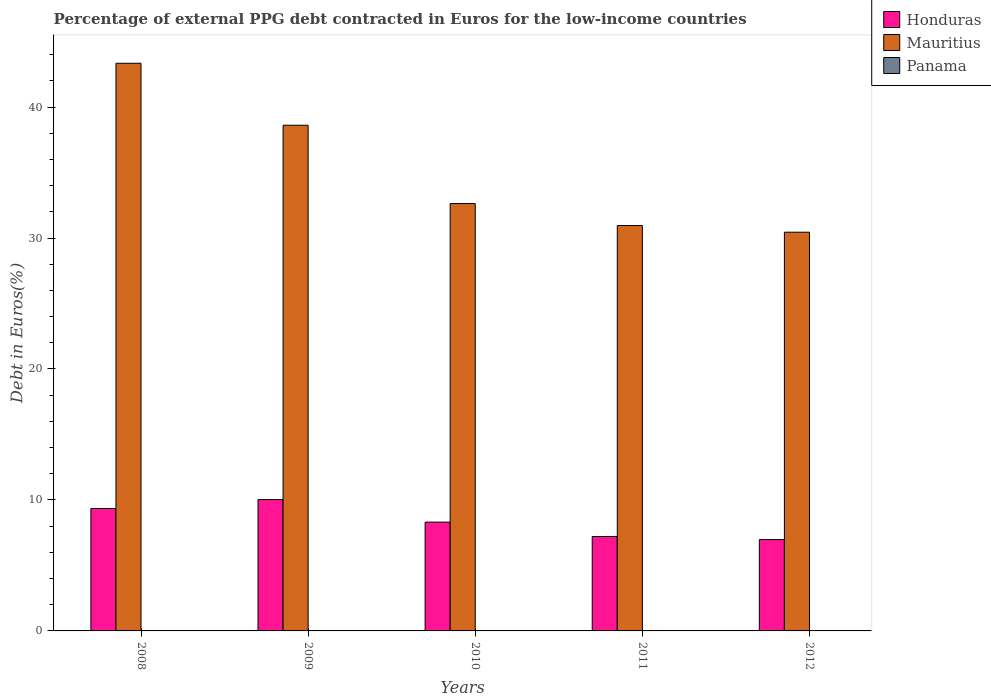How many different coloured bars are there?
Make the answer very short. 3. Are the number of bars on each tick of the X-axis equal?
Your answer should be compact. Yes. How many bars are there on the 4th tick from the left?
Provide a succinct answer. 3. How many bars are there on the 3rd tick from the right?
Provide a succinct answer. 3. What is the label of the 1st group of bars from the left?
Offer a terse response. 2008. In how many cases, is the number of bars for a given year not equal to the number of legend labels?
Keep it short and to the point. 0. What is the percentage of external PPG debt contracted in Euros in Mauritius in 2010?
Provide a short and direct response. 32.63. Across all years, what is the maximum percentage of external PPG debt contracted in Euros in Panama?
Make the answer very short. 0.03. Across all years, what is the minimum percentage of external PPG debt contracted in Euros in Panama?
Your answer should be compact. 0.01. In which year was the percentage of external PPG debt contracted in Euros in Mauritius minimum?
Your answer should be compact. 2012. What is the total percentage of external PPG debt contracted in Euros in Panama in the graph?
Your answer should be very brief. 0.08. What is the difference between the percentage of external PPG debt contracted in Euros in Honduras in 2008 and that in 2010?
Your answer should be very brief. 1.04. What is the difference between the percentage of external PPG debt contracted in Euros in Honduras in 2008 and the percentage of external PPG debt contracted in Euros in Panama in 2010?
Your answer should be very brief. 9.33. What is the average percentage of external PPG debt contracted in Euros in Honduras per year?
Offer a terse response. 8.37. In the year 2012, what is the difference between the percentage of external PPG debt contracted in Euros in Panama and percentage of external PPG debt contracted in Euros in Honduras?
Provide a short and direct response. -6.96. In how many years, is the percentage of external PPG debt contracted in Euros in Honduras greater than 6 %?
Your answer should be very brief. 5. What is the ratio of the percentage of external PPG debt contracted in Euros in Honduras in 2009 to that in 2010?
Keep it short and to the point. 1.21. Is the percentage of external PPG debt contracted in Euros in Panama in 2010 less than that in 2011?
Ensure brevity in your answer.  No. Is the difference between the percentage of external PPG debt contracted in Euros in Panama in 2011 and 2012 greater than the difference between the percentage of external PPG debt contracted in Euros in Honduras in 2011 and 2012?
Offer a terse response. No. What is the difference between the highest and the second highest percentage of external PPG debt contracted in Euros in Panama?
Offer a very short reply. 0.01. What is the difference between the highest and the lowest percentage of external PPG debt contracted in Euros in Mauritius?
Provide a succinct answer. 12.9. In how many years, is the percentage of external PPG debt contracted in Euros in Honduras greater than the average percentage of external PPG debt contracted in Euros in Honduras taken over all years?
Ensure brevity in your answer.  2. What does the 1st bar from the left in 2008 represents?
Your answer should be compact. Honduras. What does the 1st bar from the right in 2011 represents?
Your answer should be compact. Panama. Is it the case that in every year, the sum of the percentage of external PPG debt contracted in Euros in Honduras and percentage of external PPG debt contracted in Euros in Mauritius is greater than the percentage of external PPG debt contracted in Euros in Panama?
Your answer should be very brief. Yes. How many bars are there?
Keep it short and to the point. 15. Are all the bars in the graph horizontal?
Ensure brevity in your answer.  No. Are the values on the major ticks of Y-axis written in scientific E-notation?
Your response must be concise. No. Where does the legend appear in the graph?
Your response must be concise. Top right. How are the legend labels stacked?
Offer a terse response. Vertical. What is the title of the graph?
Give a very brief answer. Percentage of external PPG debt contracted in Euros for the low-income countries. Does "Italy" appear as one of the legend labels in the graph?
Your answer should be compact. No. What is the label or title of the X-axis?
Offer a very short reply. Years. What is the label or title of the Y-axis?
Your answer should be compact. Debt in Euros(%). What is the Debt in Euros(%) in Honduras in 2008?
Offer a very short reply. 9.35. What is the Debt in Euros(%) of Mauritius in 2008?
Make the answer very short. 43.35. What is the Debt in Euros(%) of Panama in 2008?
Your answer should be very brief. 0.03. What is the Debt in Euros(%) of Honduras in 2009?
Your answer should be compact. 10.03. What is the Debt in Euros(%) of Mauritius in 2009?
Provide a short and direct response. 38.61. What is the Debt in Euros(%) in Panama in 2009?
Make the answer very short. 0.02. What is the Debt in Euros(%) of Honduras in 2010?
Provide a short and direct response. 8.31. What is the Debt in Euros(%) in Mauritius in 2010?
Your answer should be very brief. 32.63. What is the Debt in Euros(%) of Panama in 2010?
Your answer should be very brief. 0.01. What is the Debt in Euros(%) of Honduras in 2011?
Give a very brief answer. 7.21. What is the Debt in Euros(%) of Mauritius in 2011?
Ensure brevity in your answer.  30.96. What is the Debt in Euros(%) in Panama in 2011?
Your response must be concise. 0.01. What is the Debt in Euros(%) in Honduras in 2012?
Keep it short and to the point. 6.97. What is the Debt in Euros(%) of Mauritius in 2012?
Your answer should be very brief. 30.45. What is the Debt in Euros(%) of Panama in 2012?
Offer a very short reply. 0.01. Across all years, what is the maximum Debt in Euros(%) in Honduras?
Your response must be concise. 10.03. Across all years, what is the maximum Debt in Euros(%) in Mauritius?
Your response must be concise. 43.35. Across all years, what is the maximum Debt in Euros(%) in Panama?
Offer a terse response. 0.03. Across all years, what is the minimum Debt in Euros(%) in Honduras?
Provide a succinct answer. 6.97. Across all years, what is the minimum Debt in Euros(%) in Mauritius?
Ensure brevity in your answer.  30.45. Across all years, what is the minimum Debt in Euros(%) of Panama?
Provide a succinct answer. 0.01. What is the total Debt in Euros(%) of Honduras in the graph?
Your response must be concise. 41.87. What is the total Debt in Euros(%) of Mauritius in the graph?
Provide a short and direct response. 175.99. What is the total Debt in Euros(%) of Panama in the graph?
Keep it short and to the point. 0.08. What is the difference between the Debt in Euros(%) of Honduras in 2008 and that in 2009?
Provide a short and direct response. -0.68. What is the difference between the Debt in Euros(%) of Mauritius in 2008 and that in 2009?
Your answer should be compact. 4.73. What is the difference between the Debt in Euros(%) in Panama in 2008 and that in 2009?
Provide a short and direct response. 0.01. What is the difference between the Debt in Euros(%) of Honduras in 2008 and that in 2010?
Provide a succinct answer. 1.04. What is the difference between the Debt in Euros(%) in Mauritius in 2008 and that in 2010?
Give a very brief answer. 10.71. What is the difference between the Debt in Euros(%) of Panama in 2008 and that in 2010?
Your response must be concise. 0.02. What is the difference between the Debt in Euros(%) of Honduras in 2008 and that in 2011?
Ensure brevity in your answer.  2.14. What is the difference between the Debt in Euros(%) of Mauritius in 2008 and that in 2011?
Make the answer very short. 12.39. What is the difference between the Debt in Euros(%) in Panama in 2008 and that in 2011?
Provide a short and direct response. 0.02. What is the difference between the Debt in Euros(%) in Honduras in 2008 and that in 2012?
Offer a very short reply. 2.38. What is the difference between the Debt in Euros(%) in Mauritius in 2008 and that in 2012?
Your answer should be compact. 12.9. What is the difference between the Debt in Euros(%) in Panama in 2008 and that in 2012?
Your answer should be compact. 0.02. What is the difference between the Debt in Euros(%) in Honduras in 2009 and that in 2010?
Your response must be concise. 1.72. What is the difference between the Debt in Euros(%) of Mauritius in 2009 and that in 2010?
Keep it short and to the point. 5.98. What is the difference between the Debt in Euros(%) in Panama in 2009 and that in 2010?
Offer a very short reply. 0. What is the difference between the Debt in Euros(%) in Honduras in 2009 and that in 2011?
Provide a succinct answer. 2.82. What is the difference between the Debt in Euros(%) of Mauritius in 2009 and that in 2011?
Offer a terse response. 7.66. What is the difference between the Debt in Euros(%) of Panama in 2009 and that in 2011?
Give a very brief answer. 0.01. What is the difference between the Debt in Euros(%) of Honduras in 2009 and that in 2012?
Provide a succinct answer. 3.06. What is the difference between the Debt in Euros(%) in Mauritius in 2009 and that in 2012?
Provide a short and direct response. 8.17. What is the difference between the Debt in Euros(%) in Panama in 2009 and that in 2012?
Provide a short and direct response. 0.01. What is the difference between the Debt in Euros(%) of Honduras in 2010 and that in 2011?
Give a very brief answer. 1.1. What is the difference between the Debt in Euros(%) in Mauritius in 2010 and that in 2011?
Provide a short and direct response. 1.68. What is the difference between the Debt in Euros(%) in Panama in 2010 and that in 2011?
Provide a short and direct response. 0. What is the difference between the Debt in Euros(%) of Honduras in 2010 and that in 2012?
Ensure brevity in your answer.  1.34. What is the difference between the Debt in Euros(%) of Mauritius in 2010 and that in 2012?
Ensure brevity in your answer.  2.19. What is the difference between the Debt in Euros(%) of Panama in 2010 and that in 2012?
Provide a succinct answer. 0. What is the difference between the Debt in Euros(%) in Honduras in 2011 and that in 2012?
Your answer should be compact. 0.24. What is the difference between the Debt in Euros(%) of Mauritius in 2011 and that in 2012?
Your answer should be compact. 0.51. What is the difference between the Debt in Euros(%) of Panama in 2011 and that in 2012?
Your answer should be compact. 0. What is the difference between the Debt in Euros(%) in Honduras in 2008 and the Debt in Euros(%) in Mauritius in 2009?
Ensure brevity in your answer.  -29.27. What is the difference between the Debt in Euros(%) of Honduras in 2008 and the Debt in Euros(%) of Panama in 2009?
Your response must be concise. 9.33. What is the difference between the Debt in Euros(%) in Mauritius in 2008 and the Debt in Euros(%) in Panama in 2009?
Your answer should be very brief. 43.33. What is the difference between the Debt in Euros(%) in Honduras in 2008 and the Debt in Euros(%) in Mauritius in 2010?
Offer a terse response. -23.28. What is the difference between the Debt in Euros(%) in Honduras in 2008 and the Debt in Euros(%) in Panama in 2010?
Make the answer very short. 9.33. What is the difference between the Debt in Euros(%) in Mauritius in 2008 and the Debt in Euros(%) in Panama in 2010?
Your response must be concise. 43.33. What is the difference between the Debt in Euros(%) in Honduras in 2008 and the Debt in Euros(%) in Mauritius in 2011?
Offer a terse response. -21.61. What is the difference between the Debt in Euros(%) in Honduras in 2008 and the Debt in Euros(%) in Panama in 2011?
Your answer should be very brief. 9.34. What is the difference between the Debt in Euros(%) of Mauritius in 2008 and the Debt in Euros(%) of Panama in 2011?
Give a very brief answer. 43.33. What is the difference between the Debt in Euros(%) of Honduras in 2008 and the Debt in Euros(%) of Mauritius in 2012?
Your answer should be very brief. -21.1. What is the difference between the Debt in Euros(%) of Honduras in 2008 and the Debt in Euros(%) of Panama in 2012?
Offer a terse response. 9.34. What is the difference between the Debt in Euros(%) in Mauritius in 2008 and the Debt in Euros(%) in Panama in 2012?
Offer a very short reply. 43.34. What is the difference between the Debt in Euros(%) in Honduras in 2009 and the Debt in Euros(%) in Mauritius in 2010?
Offer a terse response. -22.6. What is the difference between the Debt in Euros(%) of Honduras in 2009 and the Debt in Euros(%) of Panama in 2010?
Your response must be concise. 10.01. What is the difference between the Debt in Euros(%) of Mauritius in 2009 and the Debt in Euros(%) of Panama in 2010?
Offer a very short reply. 38.6. What is the difference between the Debt in Euros(%) of Honduras in 2009 and the Debt in Euros(%) of Mauritius in 2011?
Ensure brevity in your answer.  -20.93. What is the difference between the Debt in Euros(%) of Honduras in 2009 and the Debt in Euros(%) of Panama in 2011?
Your answer should be very brief. 10.02. What is the difference between the Debt in Euros(%) in Mauritius in 2009 and the Debt in Euros(%) in Panama in 2011?
Your response must be concise. 38.6. What is the difference between the Debt in Euros(%) of Honduras in 2009 and the Debt in Euros(%) of Mauritius in 2012?
Provide a succinct answer. -20.42. What is the difference between the Debt in Euros(%) of Honduras in 2009 and the Debt in Euros(%) of Panama in 2012?
Your answer should be very brief. 10.02. What is the difference between the Debt in Euros(%) in Mauritius in 2009 and the Debt in Euros(%) in Panama in 2012?
Give a very brief answer. 38.6. What is the difference between the Debt in Euros(%) in Honduras in 2010 and the Debt in Euros(%) in Mauritius in 2011?
Provide a short and direct response. -22.65. What is the difference between the Debt in Euros(%) in Honduras in 2010 and the Debt in Euros(%) in Panama in 2011?
Your response must be concise. 8.3. What is the difference between the Debt in Euros(%) of Mauritius in 2010 and the Debt in Euros(%) of Panama in 2011?
Make the answer very short. 32.62. What is the difference between the Debt in Euros(%) of Honduras in 2010 and the Debt in Euros(%) of Mauritius in 2012?
Give a very brief answer. -22.14. What is the difference between the Debt in Euros(%) in Honduras in 2010 and the Debt in Euros(%) in Panama in 2012?
Keep it short and to the point. 8.3. What is the difference between the Debt in Euros(%) of Mauritius in 2010 and the Debt in Euros(%) of Panama in 2012?
Offer a very short reply. 32.62. What is the difference between the Debt in Euros(%) of Honduras in 2011 and the Debt in Euros(%) of Mauritius in 2012?
Your response must be concise. -23.24. What is the difference between the Debt in Euros(%) in Honduras in 2011 and the Debt in Euros(%) in Panama in 2012?
Offer a very short reply. 7.2. What is the difference between the Debt in Euros(%) of Mauritius in 2011 and the Debt in Euros(%) of Panama in 2012?
Your response must be concise. 30.95. What is the average Debt in Euros(%) of Honduras per year?
Keep it short and to the point. 8.37. What is the average Debt in Euros(%) in Mauritius per year?
Give a very brief answer. 35.2. What is the average Debt in Euros(%) of Panama per year?
Your response must be concise. 0.02. In the year 2008, what is the difference between the Debt in Euros(%) in Honduras and Debt in Euros(%) in Mauritius?
Give a very brief answer. -34. In the year 2008, what is the difference between the Debt in Euros(%) of Honduras and Debt in Euros(%) of Panama?
Offer a very short reply. 9.32. In the year 2008, what is the difference between the Debt in Euros(%) in Mauritius and Debt in Euros(%) in Panama?
Your answer should be compact. 43.31. In the year 2009, what is the difference between the Debt in Euros(%) in Honduras and Debt in Euros(%) in Mauritius?
Ensure brevity in your answer.  -28.59. In the year 2009, what is the difference between the Debt in Euros(%) in Honduras and Debt in Euros(%) in Panama?
Make the answer very short. 10.01. In the year 2009, what is the difference between the Debt in Euros(%) in Mauritius and Debt in Euros(%) in Panama?
Offer a terse response. 38.6. In the year 2010, what is the difference between the Debt in Euros(%) in Honduras and Debt in Euros(%) in Mauritius?
Provide a short and direct response. -24.32. In the year 2010, what is the difference between the Debt in Euros(%) of Honduras and Debt in Euros(%) of Panama?
Give a very brief answer. 8.29. In the year 2010, what is the difference between the Debt in Euros(%) in Mauritius and Debt in Euros(%) in Panama?
Your answer should be compact. 32.62. In the year 2011, what is the difference between the Debt in Euros(%) of Honduras and Debt in Euros(%) of Mauritius?
Your response must be concise. -23.75. In the year 2011, what is the difference between the Debt in Euros(%) in Honduras and Debt in Euros(%) in Panama?
Provide a succinct answer. 7.2. In the year 2011, what is the difference between the Debt in Euros(%) in Mauritius and Debt in Euros(%) in Panama?
Your response must be concise. 30.95. In the year 2012, what is the difference between the Debt in Euros(%) of Honduras and Debt in Euros(%) of Mauritius?
Give a very brief answer. -23.47. In the year 2012, what is the difference between the Debt in Euros(%) of Honduras and Debt in Euros(%) of Panama?
Keep it short and to the point. 6.96. In the year 2012, what is the difference between the Debt in Euros(%) of Mauritius and Debt in Euros(%) of Panama?
Provide a short and direct response. 30.44. What is the ratio of the Debt in Euros(%) of Honduras in 2008 to that in 2009?
Your answer should be very brief. 0.93. What is the ratio of the Debt in Euros(%) in Mauritius in 2008 to that in 2009?
Ensure brevity in your answer.  1.12. What is the ratio of the Debt in Euros(%) of Panama in 2008 to that in 2009?
Offer a terse response. 1.89. What is the ratio of the Debt in Euros(%) in Honduras in 2008 to that in 2010?
Your response must be concise. 1.13. What is the ratio of the Debt in Euros(%) in Mauritius in 2008 to that in 2010?
Your response must be concise. 1.33. What is the ratio of the Debt in Euros(%) in Panama in 2008 to that in 2010?
Keep it short and to the point. 2.23. What is the ratio of the Debt in Euros(%) in Honduras in 2008 to that in 2011?
Provide a short and direct response. 1.3. What is the ratio of the Debt in Euros(%) in Mauritius in 2008 to that in 2011?
Ensure brevity in your answer.  1.4. What is the ratio of the Debt in Euros(%) in Honduras in 2008 to that in 2012?
Make the answer very short. 1.34. What is the ratio of the Debt in Euros(%) in Mauritius in 2008 to that in 2012?
Offer a very short reply. 1.42. What is the ratio of the Debt in Euros(%) in Panama in 2008 to that in 2012?
Ensure brevity in your answer.  3.35. What is the ratio of the Debt in Euros(%) in Honduras in 2009 to that in 2010?
Offer a terse response. 1.21. What is the ratio of the Debt in Euros(%) of Mauritius in 2009 to that in 2010?
Provide a short and direct response. 1.18. What is the ratio of the Debt in Euros(%) in Panama in 2009 to that in 2010?
Keep it short and to the point. 1.18. What is the ratio of the Debt in Euros(%) in Honduras in 2009 to that in 2011?
Make the answer very short. 1.39. What is the ratio of the Debt in Euros(%) in Mauritius in 2009 to that in 2011?
Your response must be concise. 1.25. What is the ratio of the Debt in Euros(%) of Panama in 2009 to that in 2011?
Provide a short and direct response. 1.48. What is the ratio of the Debt in Euros(%) of Honduras in 2009 to that in 2012?
Ensure brevity in your answer.  1.44. What is the ratio of the Debt in Euros(%) of Mauritius in 2009 to that in 2012?
Your response must be concise. 1.27. What is the ratio of the Debt in Euros(%) of Panama in 2009 to that in 2012?
Give a very brief answer. 1.77. What is the ratio of the Debt in Euros(%) of Honduras in 2010 to that in 2011?
Keep it short and to the point. 1.15. What is the ratio of the Debt in Euros(%) in Mauritius in 2010 to that in 2011?
Your response must be concise. 1.05. What is the ratio of the Debt in Euros(%) of Panama in 2010 to that in 2011?
Keep it short and to the point. 1.25. What is the ratio of the Debt in Euros(%) in Honduras in 2010 to that in 2012?
Ensure brevity in your answer.  1.19. What is the ratio of the Debt in Euros(%) in Mauritius in 2010 to that in 2012?
Provide a succinct answer. 1.07. What is the ratio of the Debt in Euros(%) in Panama in 2010 to that in 2012?
Ensure brevity in your answer.  1.5. What is the ratio of the Debt in Euros(%) of Honduras in 2011 to that in 2012?
Provide a short and direct response. 1.03. What is the ratio of the Debt in Euros(%) of Mauritius in 2011 to that in 2012?
Your answer should be very brief. 1.02. What is the ratio of the Debt in Euros(%) in Panama in 2011 to that in 2012?
Make the answer very short. 1.2. What is the difference between the highest and the second highest Debt in Euros(%) of Honduras?
Make the answer very short. 0.68. What is the difference between the highest and the second highest Debt in Euros(%) in Mauritius?
Your response must be concise. 4.73. What is the difference between the highest and the second highest Debt in Euros(%) of Panama?
Your response must be concise. 0.01. What is the difference between the highest and the lowest Debt in Euros(%) of Honduras?
Offer a terse response. 3.06. What is the difference between the highest and the lowest Debt in Euros(%) of Mauritius?
Provide a short and direct response. 12.9. What is the difference between the highest and the lowest Debt in Euros(%) of Panama?
Your answer should be compact. 0.02. 